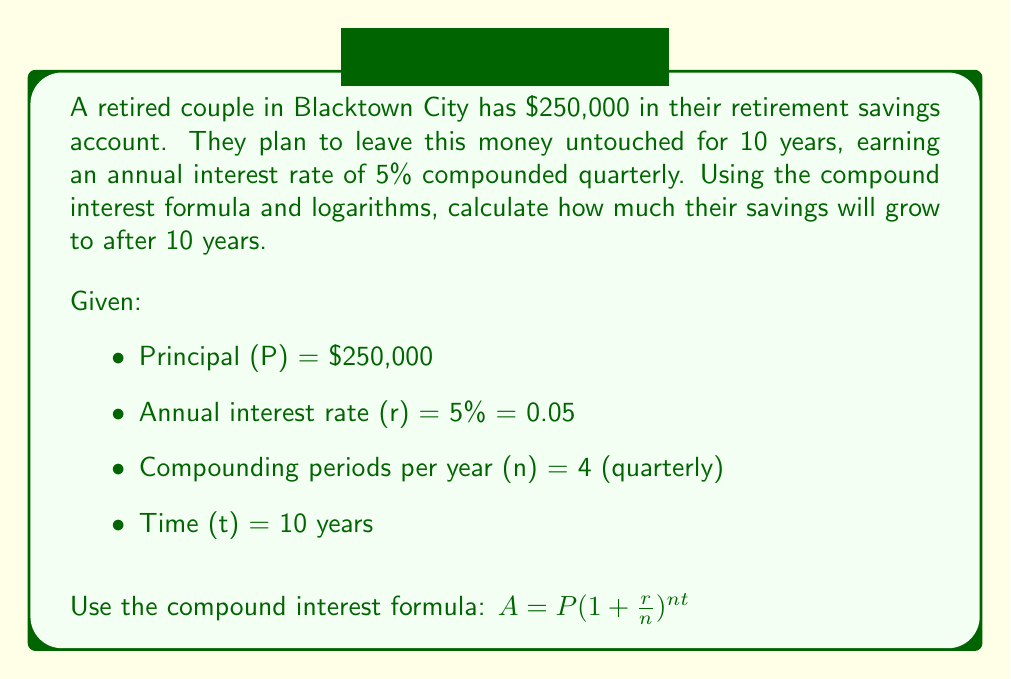Could you help me with this problem? To solve this problem, we'll use the compound interest formula and logarithms. Let's break it down step by step:

1) We start with the compound interest formula:
   $A = P(1 + \frac{r}{n})^{nt}$

2) Substitute the given values:
   $A = 250,000(1 + \frac{0.05}{4})^{4 \cdot 10}$

3) Simplify the fraction inside the parentheses:
   $A = 250,000(1 + 0.0125)^{40}$

4) Calculate the value inside the parentheses:
   $A = 250,000(1.0125)^{40}$

5) To calculate this, we can use logarithms. Let's take the natural log of both sides:
   $\ln(A) = \ln(250,000) + 40 \ln(1.0125)$

6) Calculate the logarithms:
   $\ln(A) = 12.4292 + 40 \cdot 0.0124 = 12.4292 + 0.4960 = 12.9252$

7) To get A, we need to apply the exponential function to both sides:
   $A = e^{12.9252}$

8) Calculate the final value:
   $A = 410,477.13$

Therefore, after 10 years, their savings will grow to approximately $410,477.13.
Answer: $410,477.13 